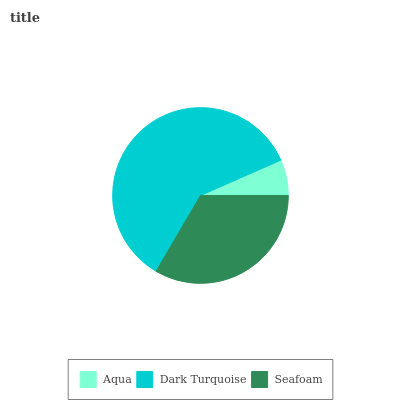Is Aqua the minimum?
Answer yes or no. Yes. Is Dark Turquoise the maximum?
Answer yes or no. Yes. Is Seafoam the minimum?
Answer yes or no. No. Is Seafoam the maximum?
Answer yes or no. No. Is Dark Turquoise greater than Seafoam?
Answer yes or no. Yes. Is Seafoam less than Dark Turquoise?
Answer yes or no. Yes. Is Seafoam greater than Dark Turquoise?
Answer yes or no. No. Is Dark Turquoise less than Seafoam?
Answer yes or no. No. Is Seafoam the high median?
Answer yes or no. Yes. Is Seafoam the low median?
Answer yes or no. Yes. Is Dark Turquoise the high median?
Answer yes or no. No. Is Aqua the low median?
Answer yes or no. No. 